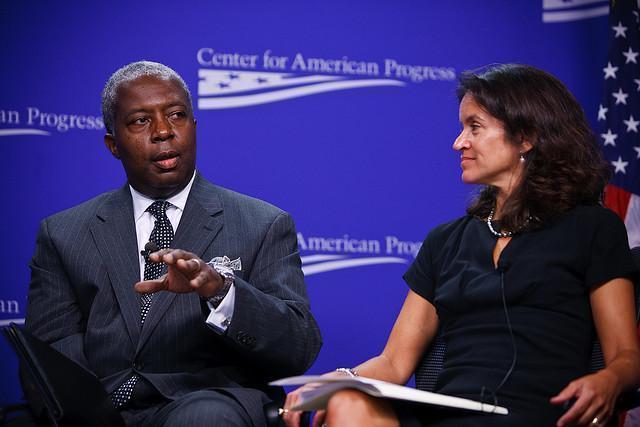What type talk is being given here?
Select the accurate response from the four choices given to answer the question.
Options: Panel, debate, argument, barnburner. Panel. 